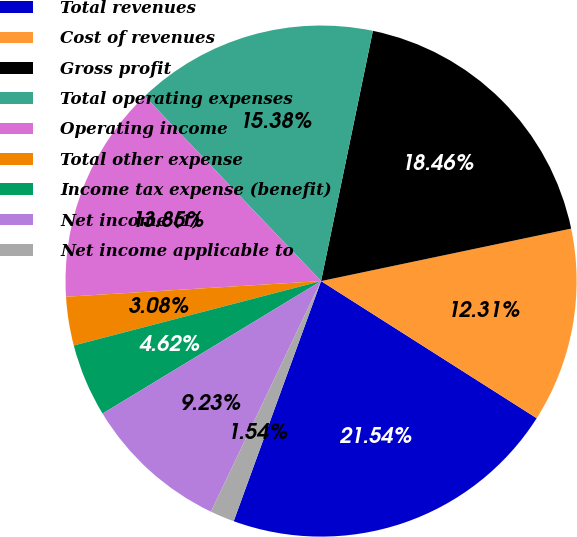Convert chart. <chart><loc_0><loc_0><loc_500><loc_500><pie_chart><fcel>Total revenues<fcel>Cost of revenues<fcel>Gross profit<fcel>Total operating expenses<fcel>Operating income<fcel>Total other expense<fcel>Income tax expense (benefit)<fcel>Net income (1)<fcel>Net income applicable to<nl><fcel>21.54%<fcel>12.31%<fcel>18.46%<fcel>15.38%<fcel>13.85%<fcel>3.08%<fcel>4.62%<fcel>9.23%<fcel>1.54%<nl></chart> 